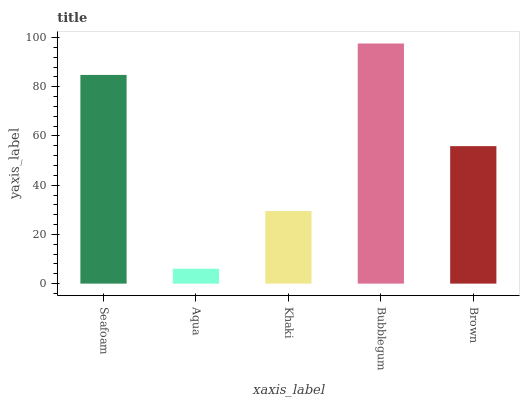Is Aqua the minimum?
Answer yes or no. Yes. Is Bubblegum the maximum?
Answer yes or no. Yes. Is Khaki the minimum?
Answer yes or no. No. Is Khaki the maximum?
Answer yes or no. No. Is Khaki greater than Aqua?
Answer yes or no. Yes. Is Aqua less than Khaki?
Answer yes or no. Yes. Is Aqua greater than Khaki?
Answer yes or no. No. Is Khaki less than Aqua?
Answer yes or no. No. Is Brown the high median?
Answer yes or no. Yes. Is Brown the low median?
Answer yes or no. Yes. Is Bubblegum the high median?
Answer yes or no. No. Is Bubblegum the low median?
Answer yes or no. No. 